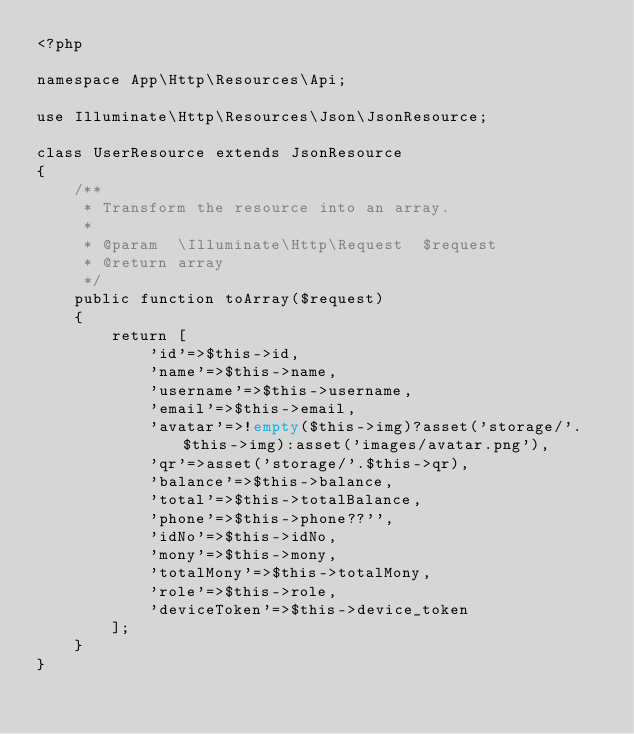<code> <loc_0><loc_0><loc_500><loc_500><_PHP_><?php

namespace App\Http\Resources\Api;

use Illuminate\Http\Resources\Json\JsonResource;

class UserResource extends JsonResource
{
    /**
     * Transform the resource into an array.
     *
     * @param  \Illuminate\Http\Request  $request
     * @return array
     */
    public function toArray($request)
    {
        return [
            'id'=>$this->id,
            'name'=>$this->name,
            'username'=>$this->username,
            'email'=>$this->email,
            'avatar'=>!empty($this->img)?asset('storage/'.$this->img):asset('images/avatar.png'),
            'qr'=>asset('storage/'.$this->qr),
            'balance'=>$this->balance,
            'total'=>$this->totalBalance,
            'phone'=>$this->phone??'',
            'idNo'=>$this->idNo,
            'mony'=>$this->mony,
            'totalMony'=>$this->totalMony,
            'role'=>$this->role,
            'deviceToken'=>$this->device_token
        ];
    }
}
</code> 